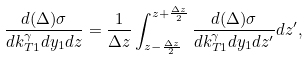<formula> <loc_0><loc_0><loc_500><loc_500>\frac { d ( \Delta ) \sigma } { d k ^ { \gamma } _ { T 1 } d y _ { 1 } d z } = \frac { 1 } { \Delta z } \int ^ { z + \frac { \Delta z } { 2 } } _ { z - \frac { \Delta z } { 2 } } \frac { d ( \Delta ) \sigma } { d k ^ { \gamma } _ { T 1 } d y _ { 1 } d z ^ { \prime } } d z ^ { \prime } ,</formula> 